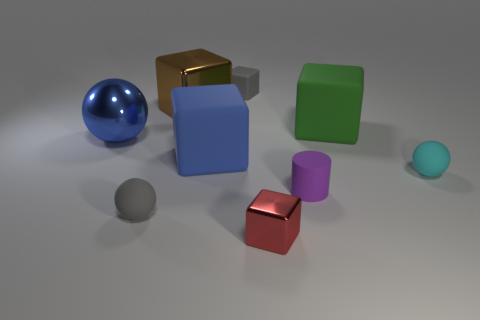Subtract all matte balls. How many balls are left? 1 Subtract 4 blocks. How many blocks are left? 1 Subtract all brown cubes. How many cubes are left? 4 Subtract all cubes. How many objects are left? 4 Add 3 small gray objects. How many small gray objects are left? 5 Add 4 large cyan shiny cylinders. How many large cyan shiny cylinders exist? 4 Subtract 0 brown cylinders. How many objects are left? 9 Subtract all yellow cylinders. Subtract all green cubes. How many cylinders are left? 1 Subtract all small cyan things. Subtract all purple matte cylinders. How many objects are left? 7 